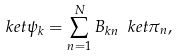Convert formula to latex. <formula><loc_0><loc_0><loc_500><loc_500>\ k e t { \psi _ { k } } = \sum _ { n = 1 } ^ { N } B _ { k n } \ k e t { \pi _ { n } } ,</formula> 